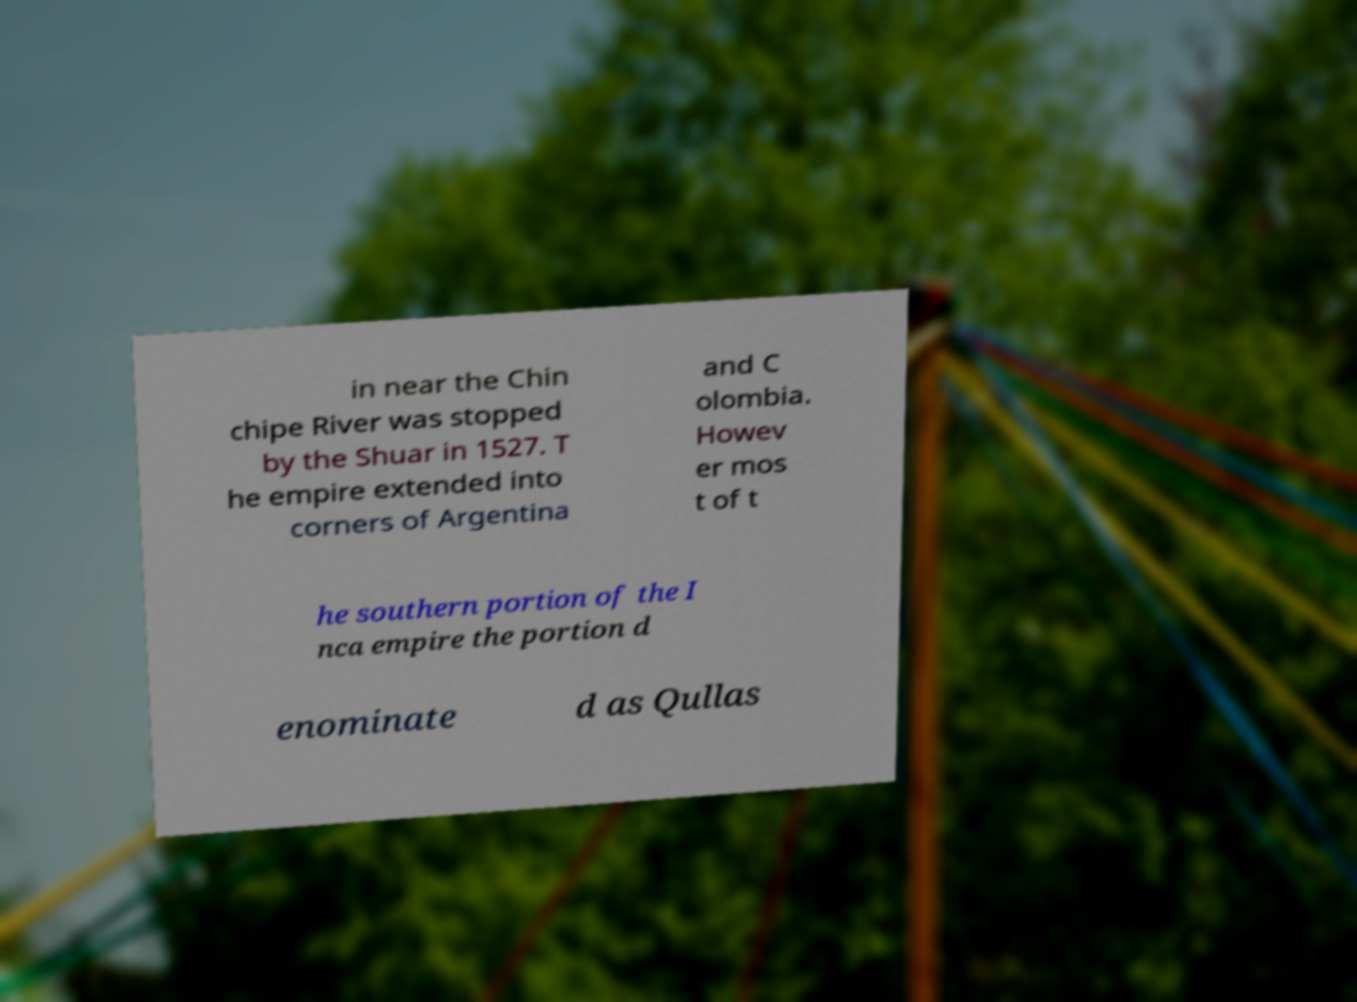What messages or text are displayed in this image? I need them in a readable, typed format. in near the Chin chipe River was stopped by the Shuar in 1527. T he empire extended into corners of Argentina and C olombia. Howev er mos t of t he southern portion of the I nca empire the portion d enominate d as Qullas 